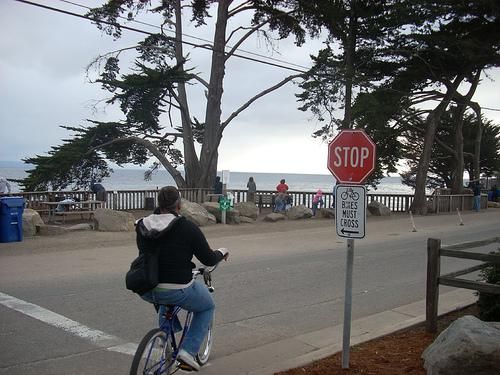Question: who is on the bicycle?
Choices:
A. A man.
B. A person.
C. A woman.
D. A child.
Answer with the letter. Answer: B Question: where is the road?
Choices:
A. Under the bicycle.
B. Beside the bicycle.
C. Behind the bicycle.
D. Away from the bicycle.
Answer with the letter. Answer: B Question: how does the weather look?
Choices:
A. Sunny.
B. Cloudy.
C. Foggy.
D. Rainy.
Answer with the letter. Answer: B Question: how is the lighting?
Choices:
A. Bright.
B. Dim.
C. Dark.
D. Medium.
Answer with the letter. Answer: B 